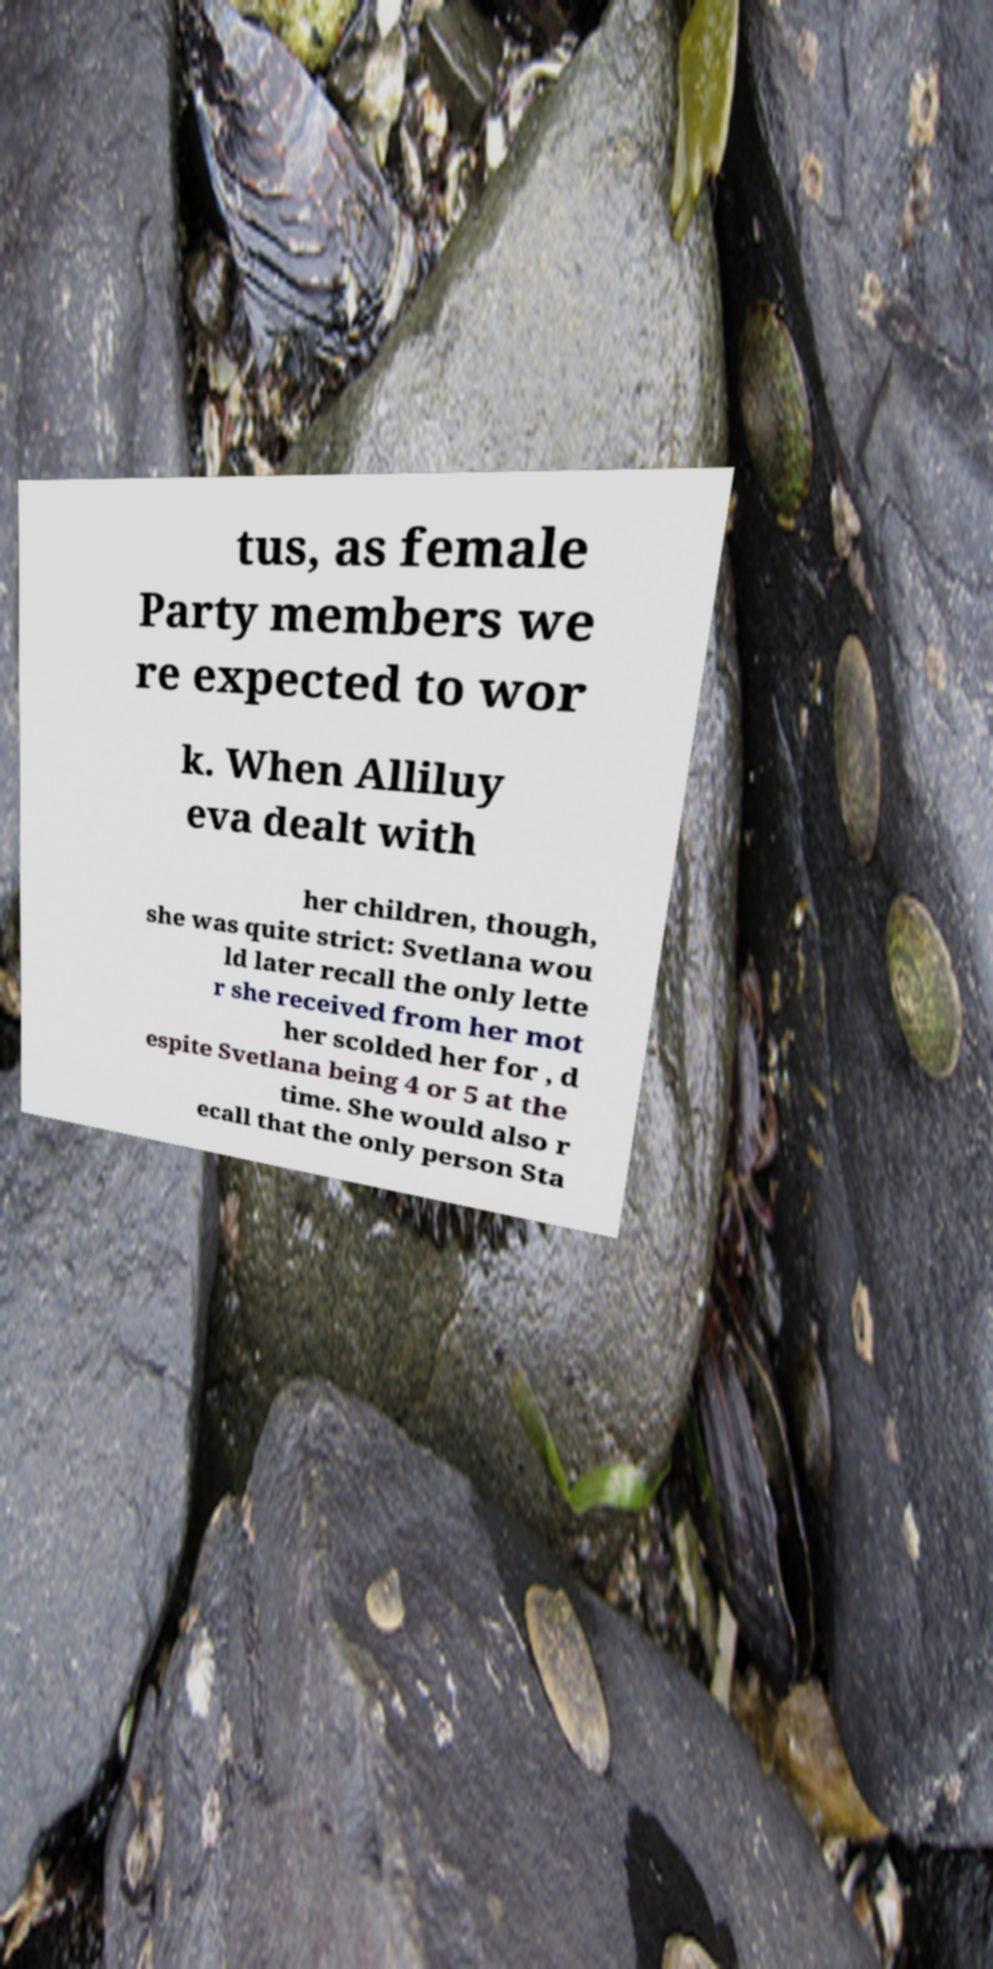There's text embedded in this image that I need extracted. Can you transcribe it verbatim? tus, as female Party members we re expected to wor k. When Alliluy eva dealt with her children, though, she was quite strict: Svetlana wou ld later recall the only lette r she received from her mot her scolded her for , d espite Svetlana being 4 or 5 at the time. She would also r ecall that the only person Sta 